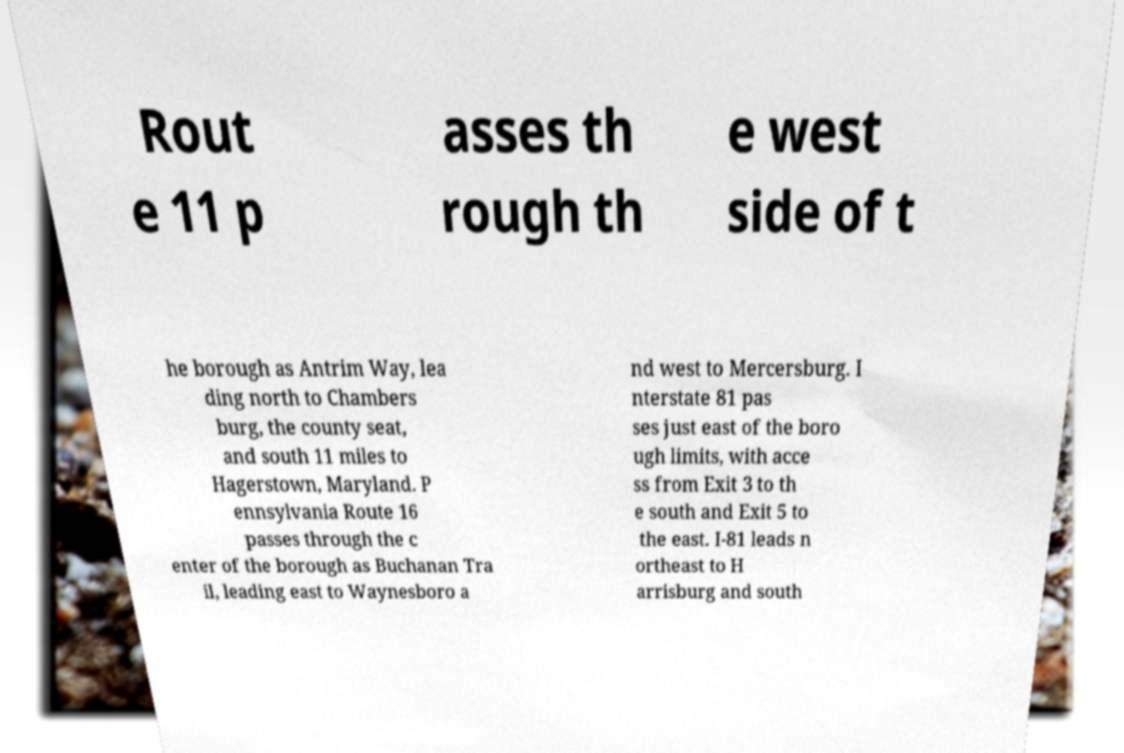I need the written content from this picture converted into text. Can you do that? Rout e 11 p asses th rough th e west side of t he borough as Antrim Way, lea ding north to Chambers burg, the county seat, and south 11 miles to Hagerstown, Maryland. P ennsylvania Route 16 passes through the c enter of the borough as Buchanan Tra il, leading east to Waynesboro a nd west to Mercersburg. I nterstate 81 pas ses just east of the boro ugh limits, with acce ss from Exit 3 to th e south and Exit 5 to the east. I-81 leads n ortheast to H arrisburg and south 